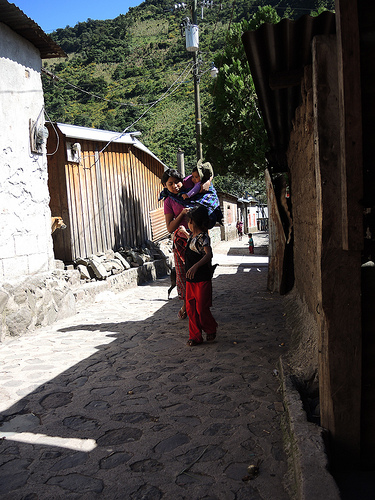<image>
Is the baby on the child? No. The baby is not positioned on the child. They may be near each other, but the baby is not supported by or resting on top of the child. 